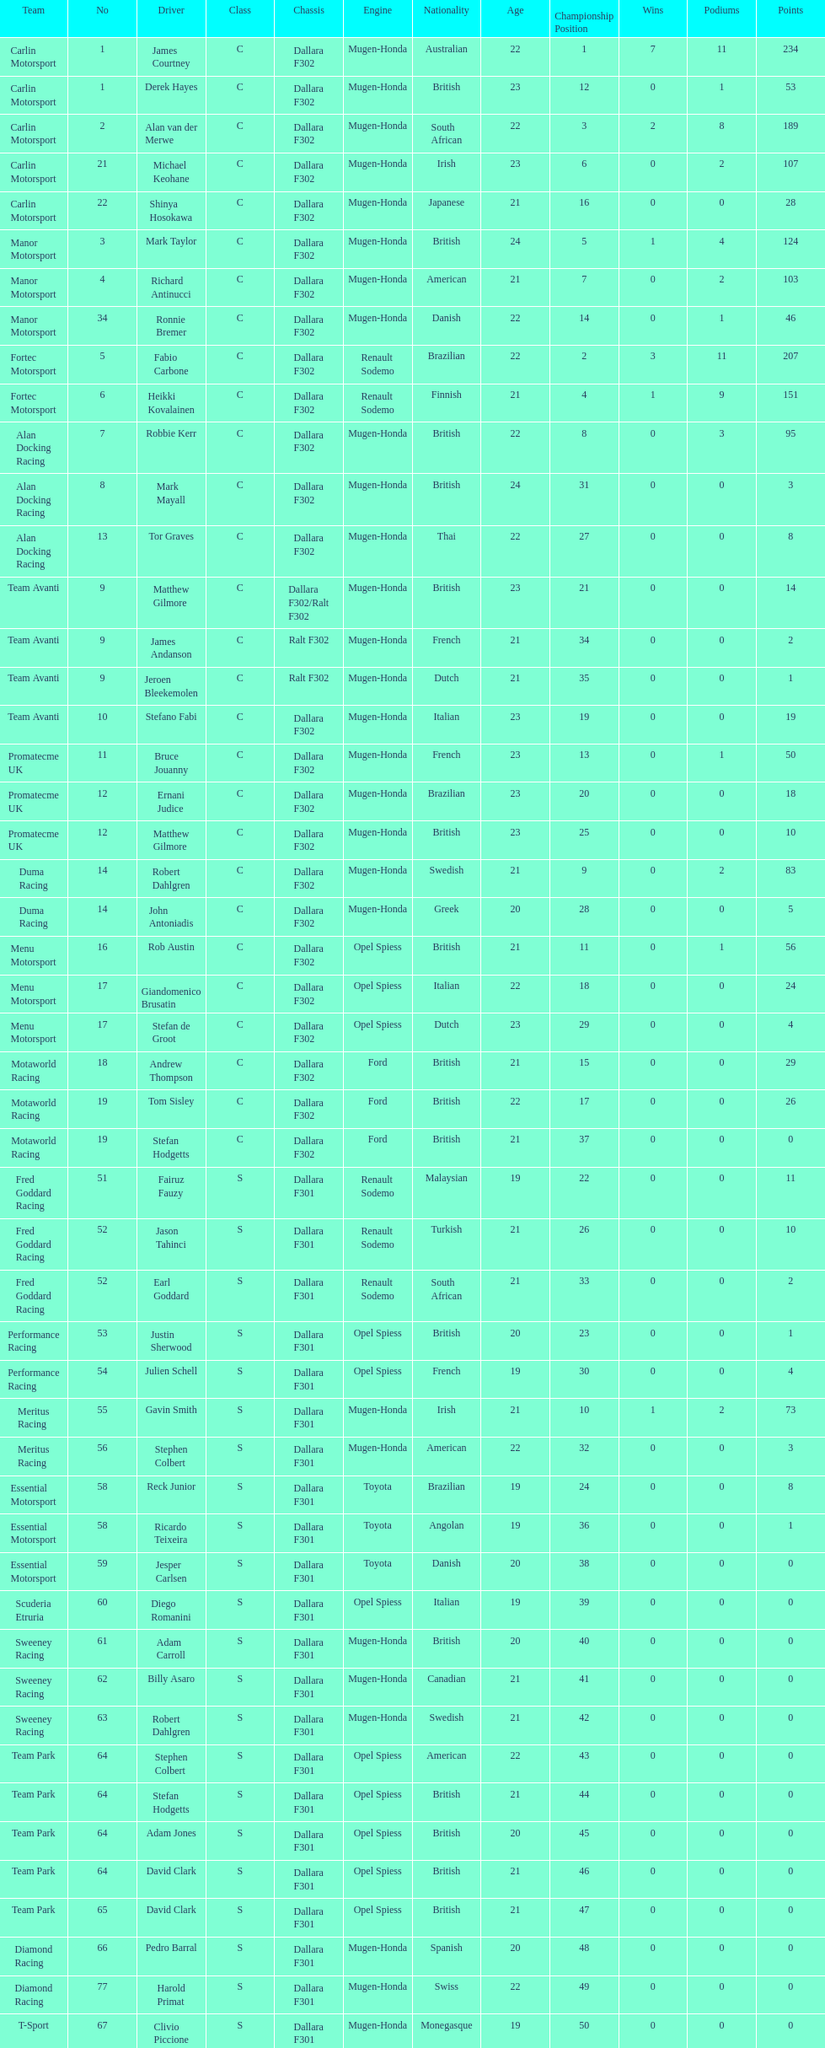Who had more drivers, team avanti or motaworld racing? Team Avanti. 